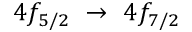Convert formula to latex. <formula><loc_0><loc_0><loc_500><loc_500>4 f _ { 5 / 2 } \ \rightarrow \ 4 f _ { 7 / 2 }</formula> 